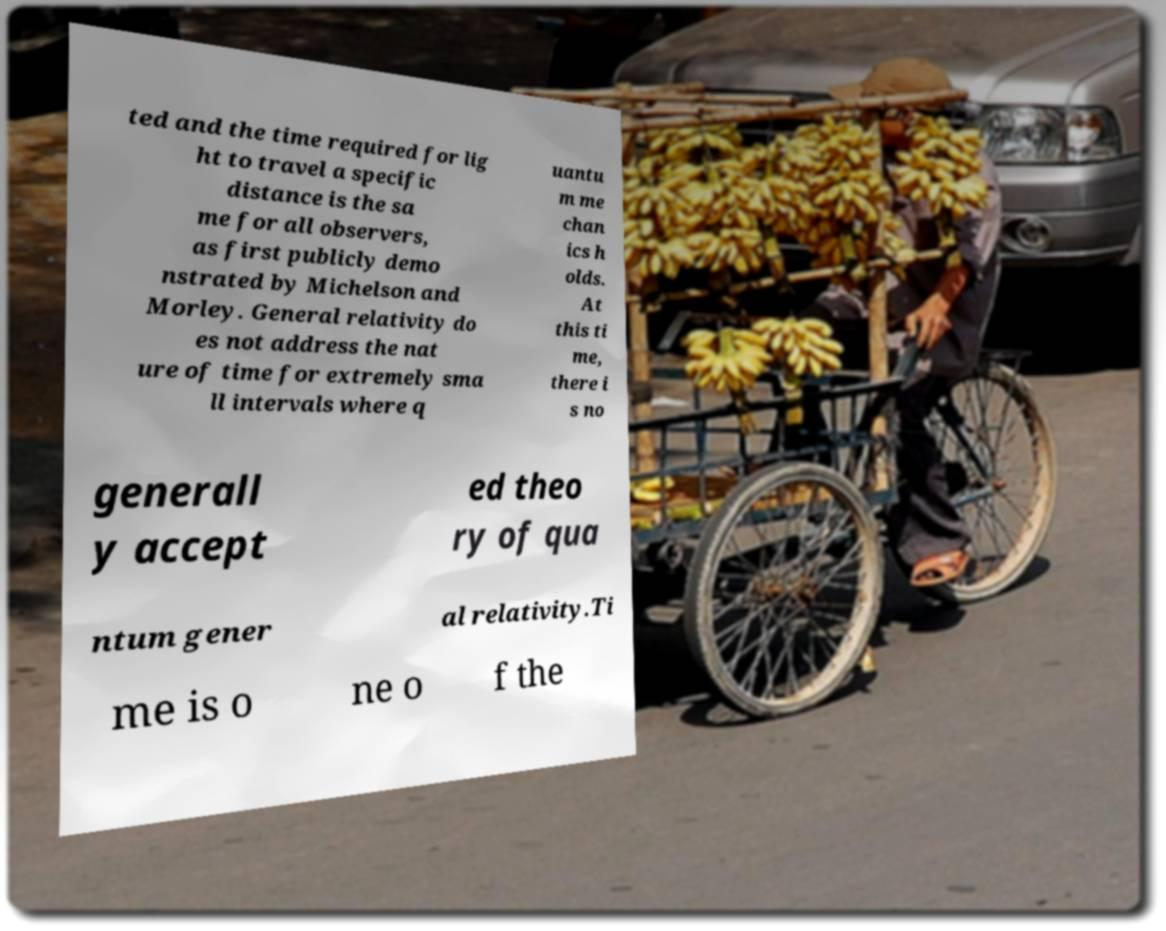For documentation purposes, I need the text within this image transcribed. Could you provide that? ted and the time required for lig ht to travel a specific distance is the sa me for all observers, as first publicly demo nstrated by Michelson and Morley. General relativity do es not address the nat ure of time for extremely sma ll intervals where q uantu m me chan ics h olds. At this ti me, there i s no generall y accept ed theo ry of qua ntum gener al relativity.Ti me is o ne o f the 